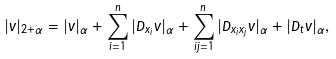Convert formula to latex. <formula><loc_0><loc_0><loc_500><loc_500>| v | _ { 2 + \alpha } = | v | _ { \alpha } + \sum _ { i = 1 } ^ { n } | D _ { x _ { i } } v | _ { \alpha } + \sum _ { i j = 1 } ^ { n } | D _ { x _ { i } x _ { j } } v | _ { \alpha } + | D _ { t } v | _ { \alpha } ,</formula> 